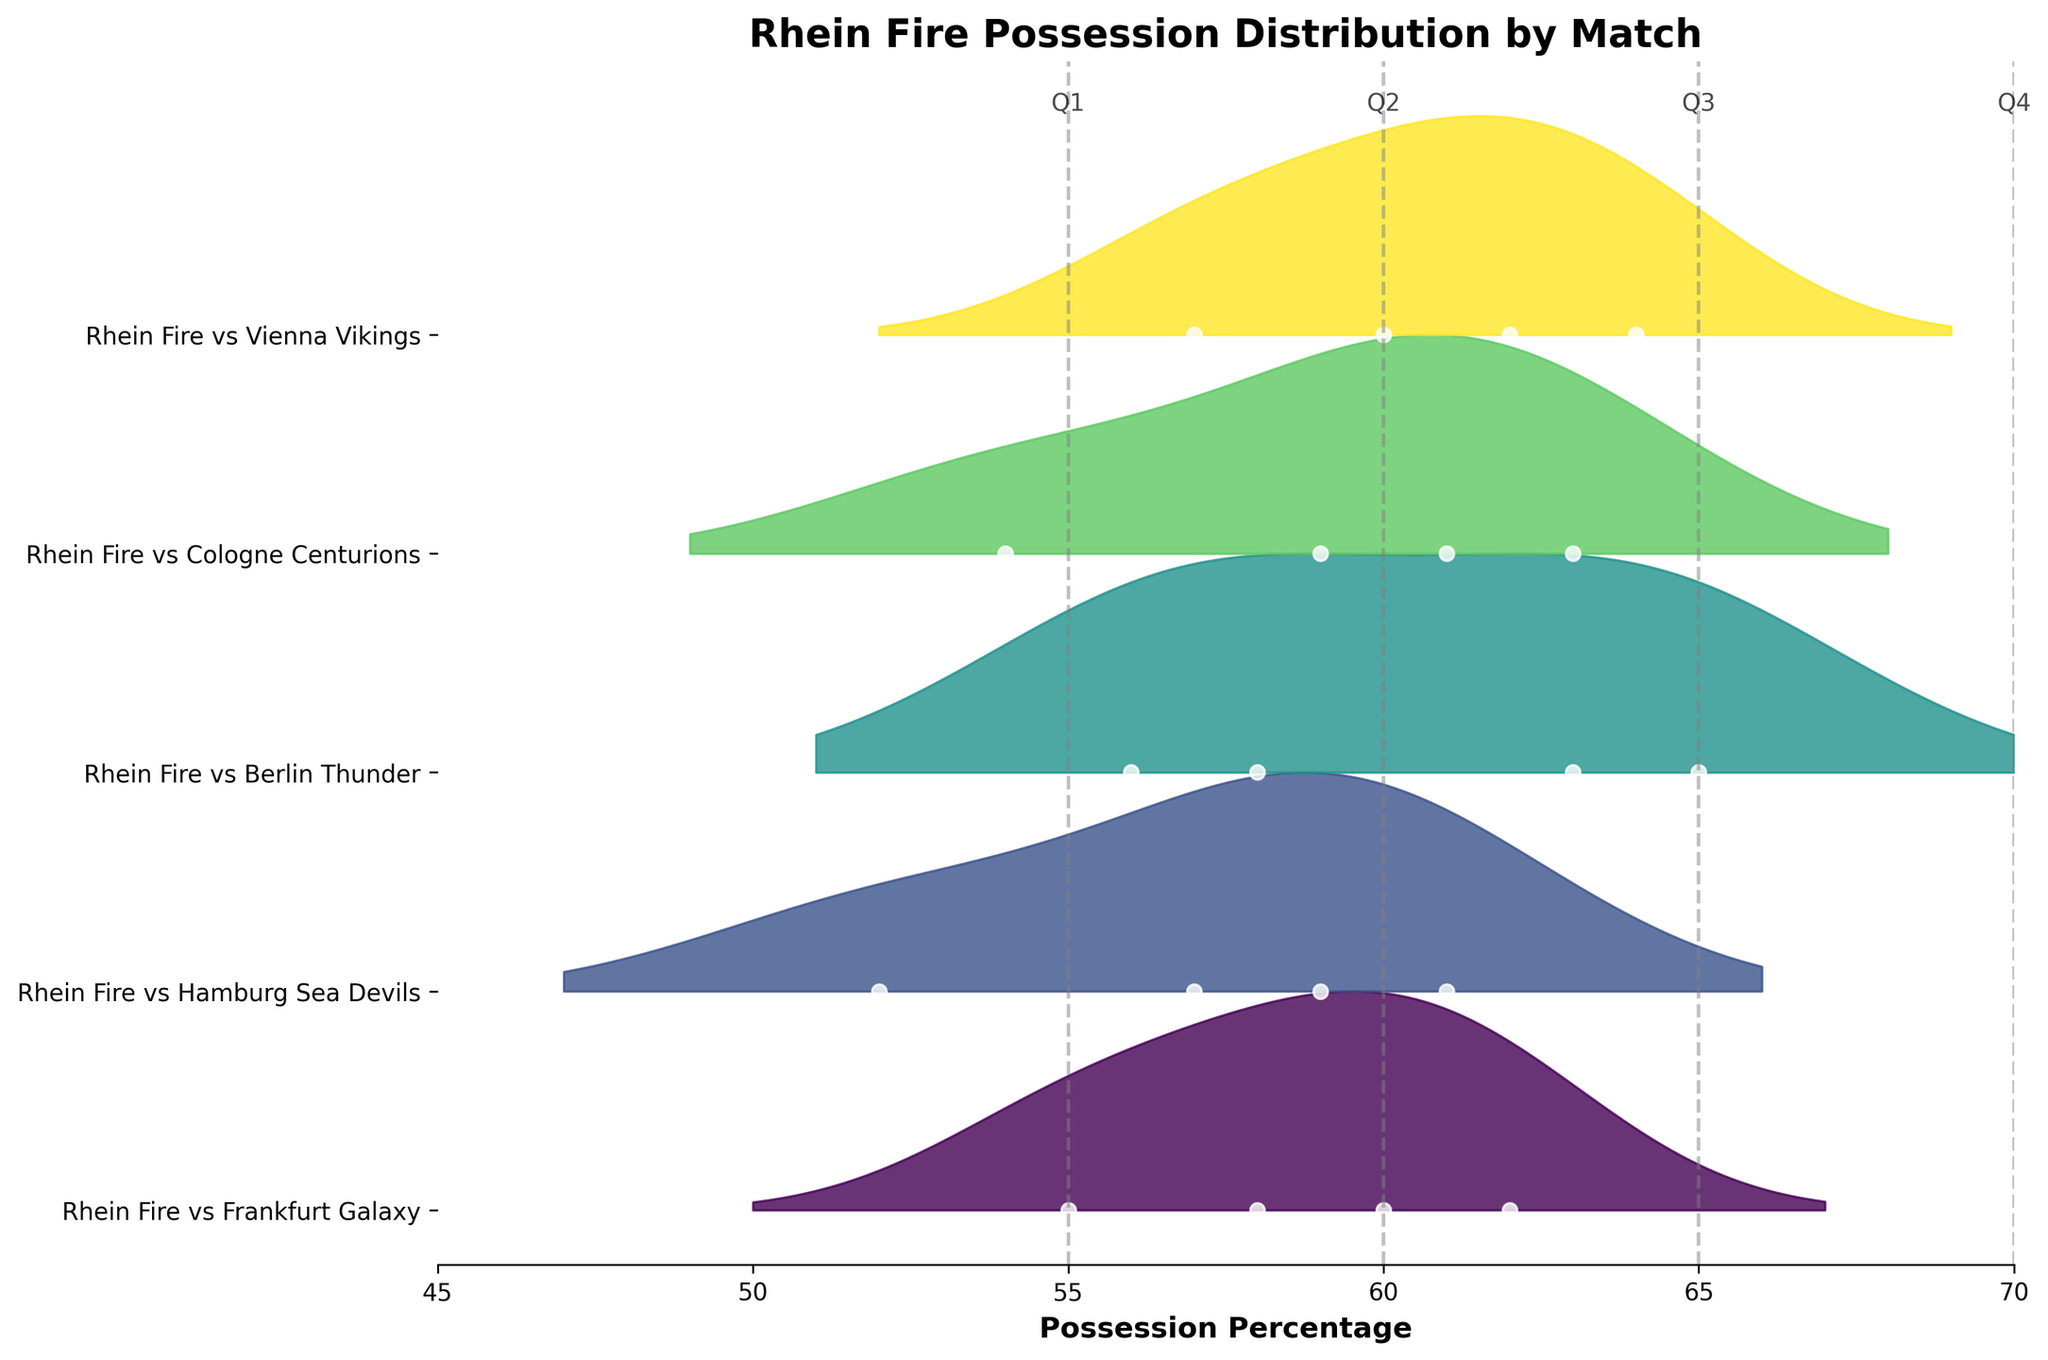What's the title of the figure? The title is located at the top of the figure and provides a summary of what the plot represents.
Answer: Rhein Fire Possession Distribution by Match How many matches are included in the figure? You can count the number of labels on the y-axis, as each label corresponds to a different match.
Answer: 5 What is the possession percentage range shown on the x-axis? This can be determined by looking at the minimum and maximum values on the x-axis.
Answer: 45 to 70 During which match did Rhein Fire have the highest possession percentage in the first quarter (Q1)? By examining the points plotted for Q1 across all matches, locate the highest value.
Answer: Rhein Fire vs Berlin Thunder What is the average possession percentage in the third quarter (Q3) across all matches? Find the Q3 possession percentage for each match, sum these values, and then divide by the number of matches.
Answer: (55 + 61 + 58 + 63 + 64) / 5 = 60.2 Which quarter shows the greatest variation in possession percentage? Observe the densities and spreads of the distributions for each quarter; the quarter with the widest spread indicates the greatest variation.
Answer: Q1 Is there a match where Rhein Fire's possession percentage consistently increased across all quarters? Evaluate each match and see if the possession percentage rises from Q1 through Q4 without decreasing.
Answer: No Which match has the lowest median possession percentage? By examining the middle values of the distributions for each match, identify the one with the lowest median position.
Answer: Rhein Fire vs Hamburg Sea Devils Does Rhein Fire tend to have higher possession percentages in the first half (Q1 and Q2) or the second half (Q3 and Q4) of matches? Compare the possession percentages for Q1 and Q2 against Q3 and Q4 for each match, then average them for the overall trend.
Answer: Second half How does the possession distribution vary between Rhein Fire vs Berlin Thunder and Rhein Fire vs Vienna Vikings? Compare the density spreads and the position of the points for these two matches to see if their distributions differ significantly.
Answer: Berlin Thunder has higher densities in the lower range, Vienna Vikings are more spread out around higher values 